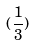<formula> <loc_0><loc_0><loc_500><loc_500>( \frac { 1 } { 3 } )</formula> 